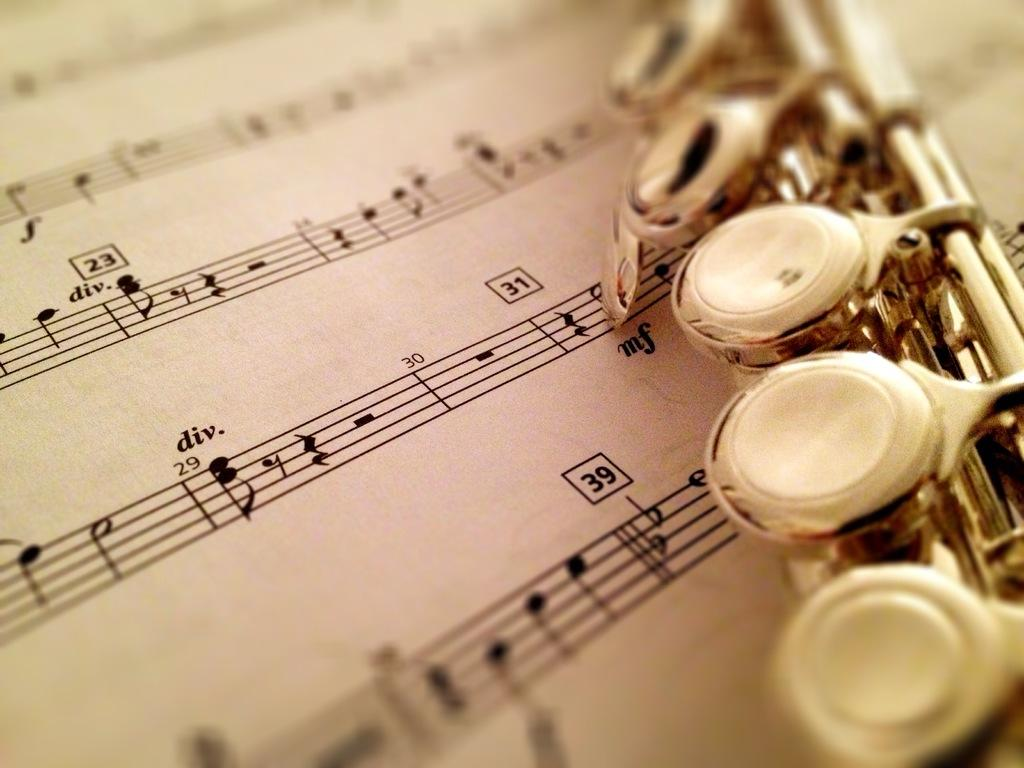What is the main object in the foreground of the image? There is a musical instrument and a chart in the foreground of the image. Can you describe the musical instrument in the image? Unfortunately, the specific type of musical instrument cannot be determined from the provided facts. What is the purpose of the chart in the image? The purpose of the chart cannot be determined from the provided facts. Where might this image have been taken? The image may have been taken in a room, but the specific location cannot be determined from the provided facts. What type of underwear is the person wearing in the image? There is no person visible in the image, and therefore no underwear can be observed. What book is the person reading in the image? There is no person or book visible in the image. 